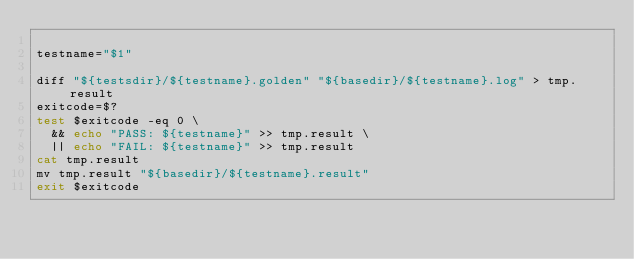Convert code to text. <code><loc_0><loc_0><loc_500><loc_500><_Bash_>
testname="$1"

diff "${testsdir}/${testname}.golden" "${basedir}/${testname}.log" > tmp.result
exitcode=$?
test $exitcode -eq 0 \
  && echo "PASS: ${testname}" >> tmp.result \
  || echo "FAIL: ${testname}" >> tmp.result
cat tmp.result
mv tmp.result "${basedir}/${testname}.result"
exit $exitcode
</code> 